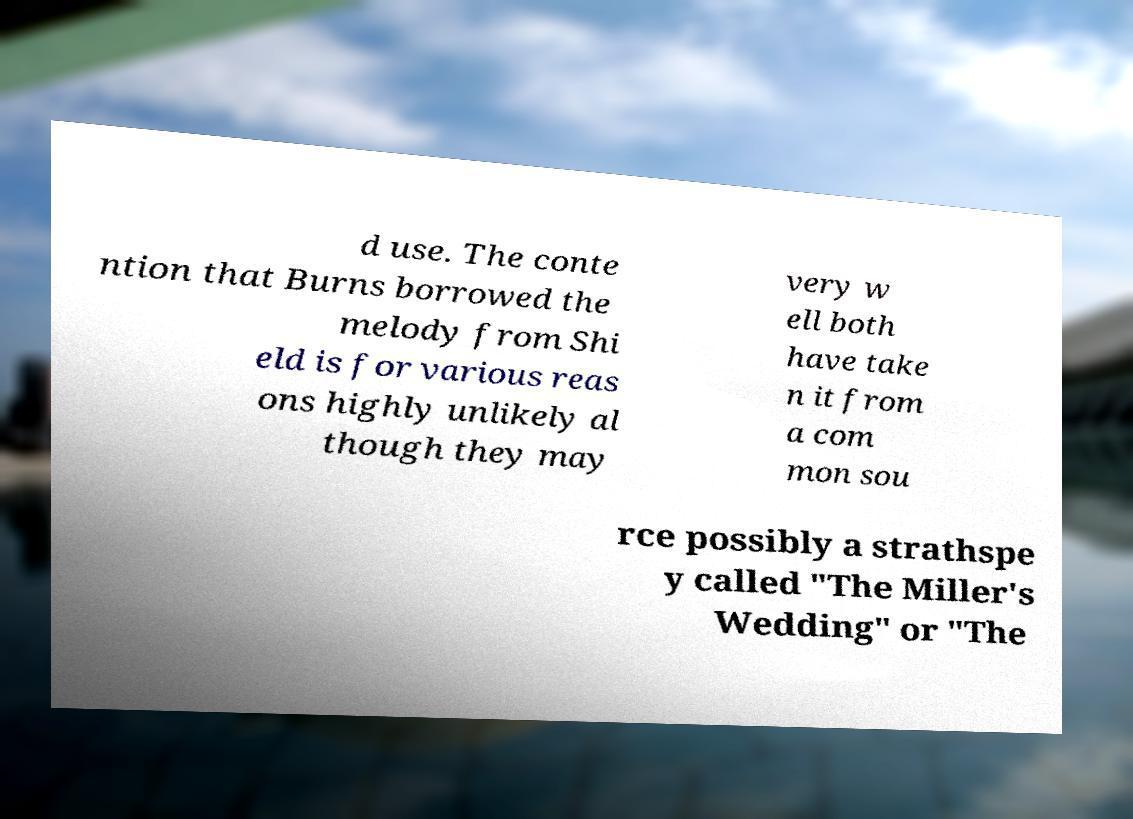Could you assist in decoding the text presented in this image and type it out clearly? d use. The conte ntion that Burns borrowed the melody from Shi eld is for various reas ons highly unlikely al though they may very w ell both have take n it from a com mon sou rce possibly a strathspe y called "The Miller's Wedding" or "The 